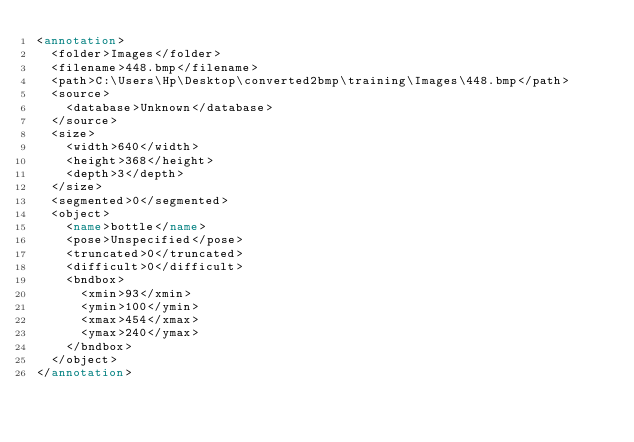Convert code to text. <code><loc_0><loc_0><loc_500><loc_500><_XML_><annotation>
	<folder>Images</folder>
	<filename>448.bmp</filename>
	<path>C:\Users\Hp\Desktop\converted2bmp\training\Images\448.bmp</path>
	<source>
		<database>Unknown</database>
	</source>
	<size>
		<width>640</width>
		<height>368</height>
		<depth>3</depth>
	</size>
	<segmented>0</segmented>
	<object>
		<name>bottle</name>
		<pose>Unspecified</pose>
		<truncated>0</truncated>
		<difficult>0</difficult>
		<bndbox>
			<xmin>93</xmin>
			<ymin>100</ymin>
			<xmax>454</xmax>
			<ymax>240</ymax>
		</bndbox>
	</object>
</annotation>
</code> 